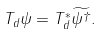Convert formula to latex. <formula><loc_0><loc_0><loc_500><loc_500>T _ { d } \psi = T _ { d } ^ { \ast } \widetilde { \psi ^ { \dag } } .</formula> 